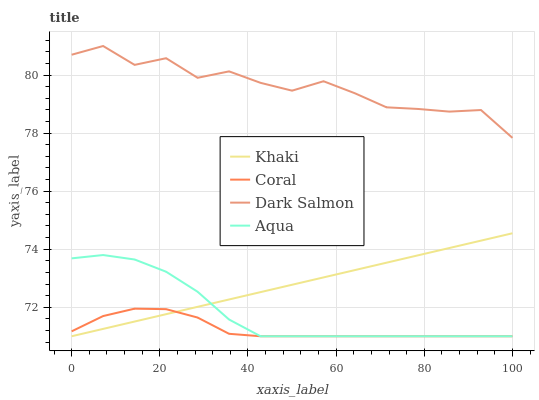Does Coral have the minimum area under the curve?
Answer yes or no. Yes. Does Dark Salmon have the maximum area under the curve?
Answer yes or no. Yes. Does Khaki have the minimum area under the curve?
Answer yes or no. No. Does Khaki have the maximum area under the curve?
Answer yes or no. No. Is Khaki the smoothest?
Answer yes or no. Yes. Is Dark Salmon the roughest?
Answer yes or no. Yes. Is Aqua the smoothest?
Answer yes or no. No. Is Aqua the roughest?
Answer yes or no. No. Does Coral have the lowest value?
Answer yes or no. Yes. Does Dark Salmon have the lowest value?
Answer yes or no. No. Does Dark Salmon have the highest value?
Answer yes or no. Yes. Does Khaki have the highest value?
Answer yes or no. No. Is Coral less than Dark Salmon?
Answer yes or no. Yes. Is Dark Salmon greater than Khaki?
Answer yes or no. Yes. Does Aqua intersect Coral?
Answer yes or no. Yes. Is Aqua less than Coral?
Answer yes or no. No. Is Aqua greater than Coral?
Answer yes or no. No. Does Coral intersect Dark Salmon?
Answer yes or no. No. 